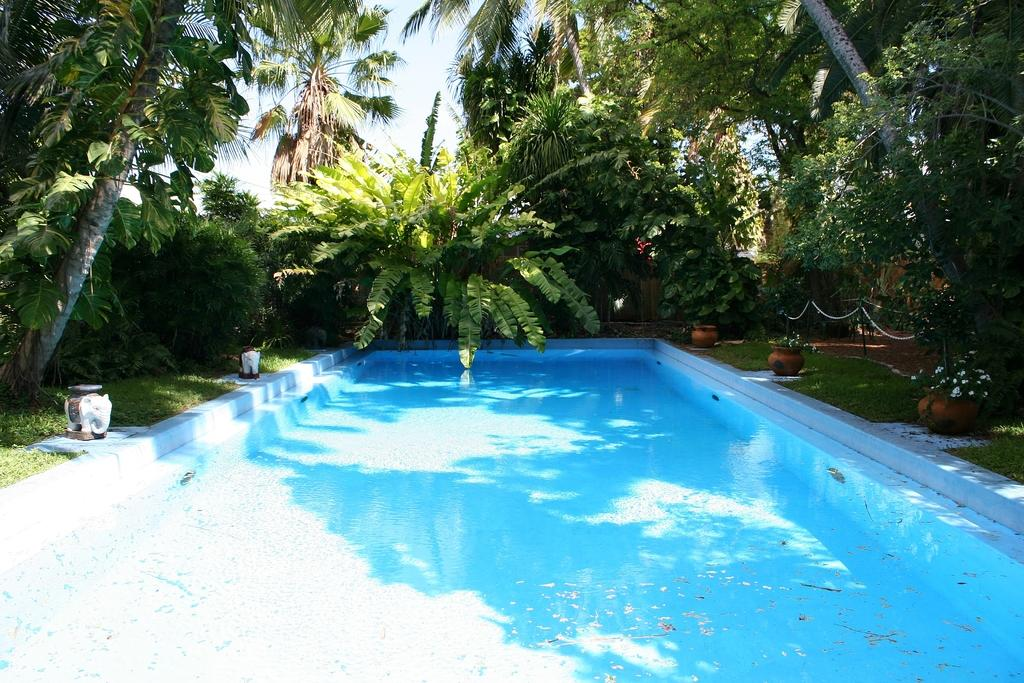What is the main feature in the image? There is a swimming pool in the image. What can be seen on the left side of the image? There are objects on the left side of the image. Are there any plants visible in the image? Yes, there are potted plants in the image. What is visible in the background of the image? There are trees and the sky visible in the background of the image. What type of suit is the actor wearing while swimming in the pool? There is no actor or suit present in the image; it features a swimming pool and other objects. How many lizards can be seen climbing the trees in the background? There are no lizards visible in the image; only trees and the sky are present in the background. 